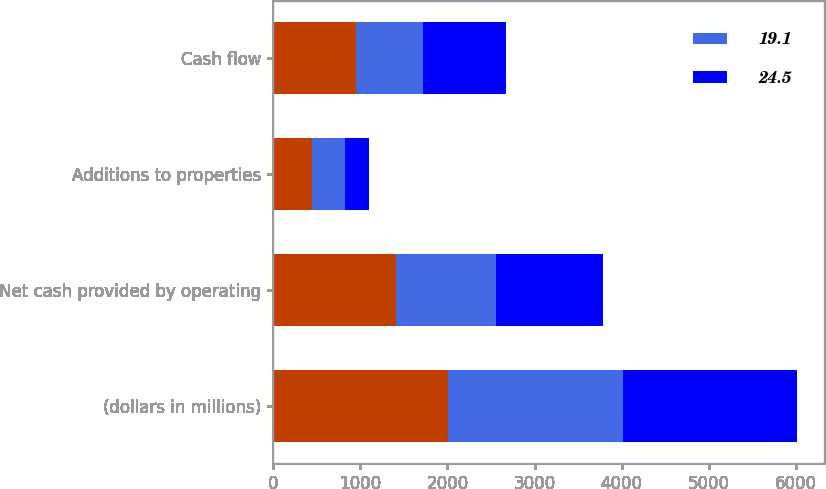<chart> <loc_0><loc_0><loc_500><loc_500><stacked_bar_chart><ecel><fcel>(dollars in millions)<fcel>Net cash provided by operating<fcel>Additions to properties<fcel>Cash flow<nl><fcel>nan<fcel>2006<fcel>1410.5<fcel>453.1<fcel>957.4<nl><fcel>19.1<fcel>2005<fcel>1143.3<fcel>374.2<fcel>769.1<nl><fcel>24.5<fcel>2004<fcel>1229<fcel>278.6<fcel>950.4<nl></chart> 